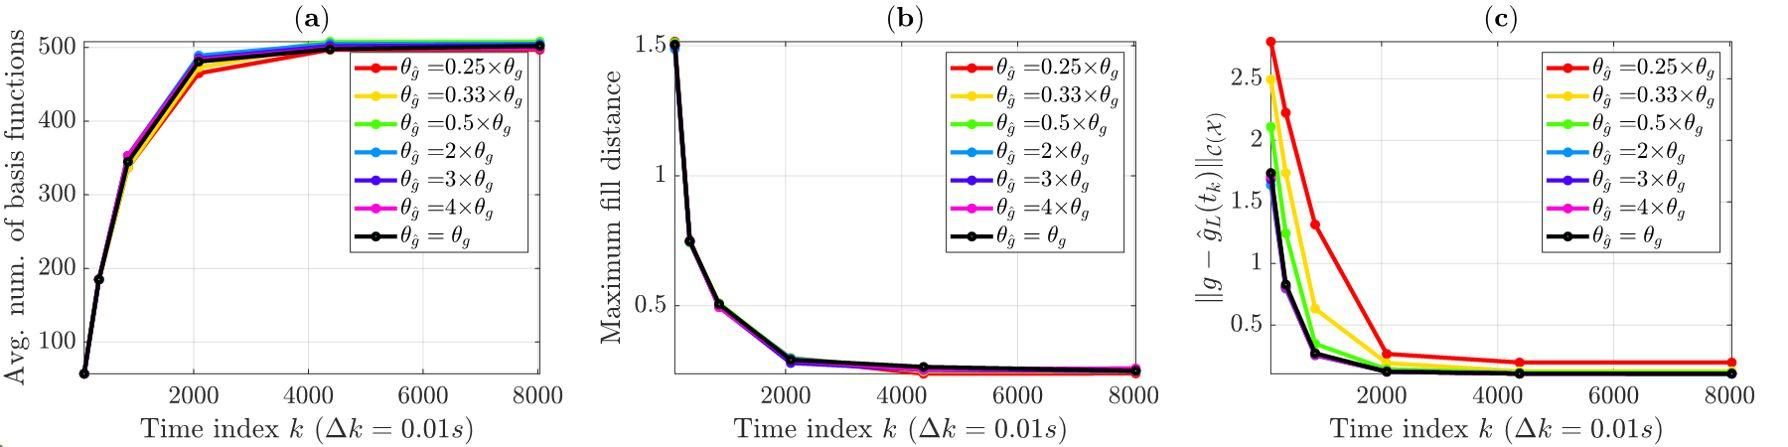Based on figure (b), what can be inferred about the maximum fill distance over time? A. The maximum fill distance increases over time. B. The maximum fill distance decreases and then increases over time. C. The maximum fill distance decreases over time. D. The maximum fill distance remains constant over time. Figure (b) shows that the maximum fill distance decreases sharply initially and then remains constant at a minimal value for all values of θ_j, indicating a stabilization over time. Therefore, the correct answer is C. 